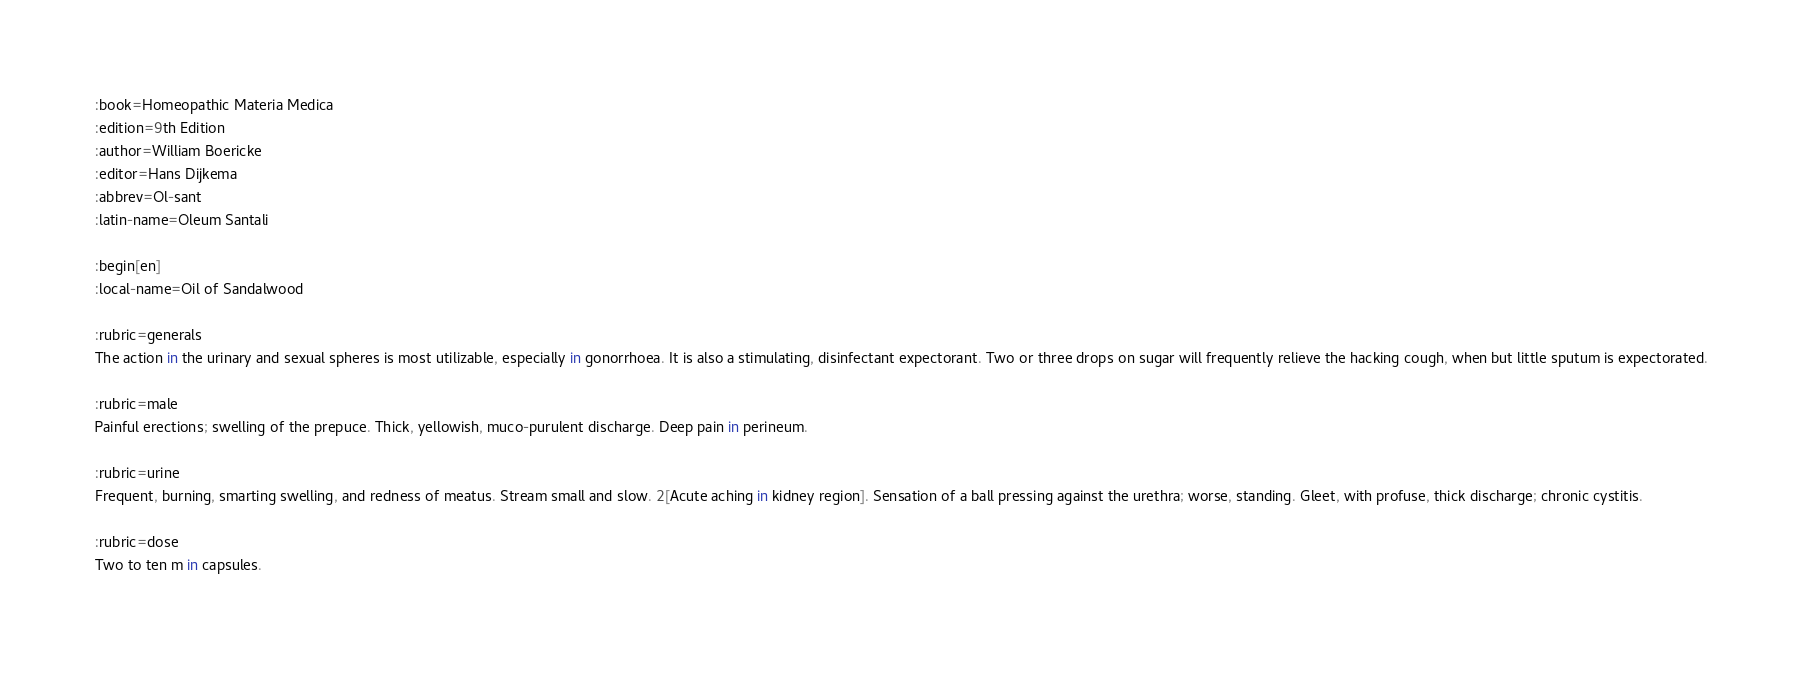Convert code to text. <code><loc_0><loc_0><loc_500><loc_500><_ObjectiveC_>:book=Homeopathic Materia Medica
:edition=9th Edition
:author=William Boericke
:editor=Hans Dijkema
:abbrev=Ol-sant
:latin-name=Oleum Santali

:begin[en]
:local-name=Oil of Sandalwood

:rubric=generals
The action in the urinary and sexual spheres is most utilizable, especially in gonorrhoea. It is also a stimulating, disinfectant expectorant. Two or three drops on sugar will frequently relieve the hacking cough, when but little sputum is expectorated.

:rubric=male
Painful erections; swelling of the prepuce. Thick, yellowish, muco-purulent discharge. Deep pain in perineum.

:rubric=urine
Frequent, burning, smarting swelling, and redness of meatus. Stream small and slow. 2[Acute aching in kidney region]. Sensation of a ball pressing against the urethra; worse, standing. Gleet, with profuse, thick discharge; chronic cystitis.

:rubric=dose
Two to ten m in capsules.

</code> 